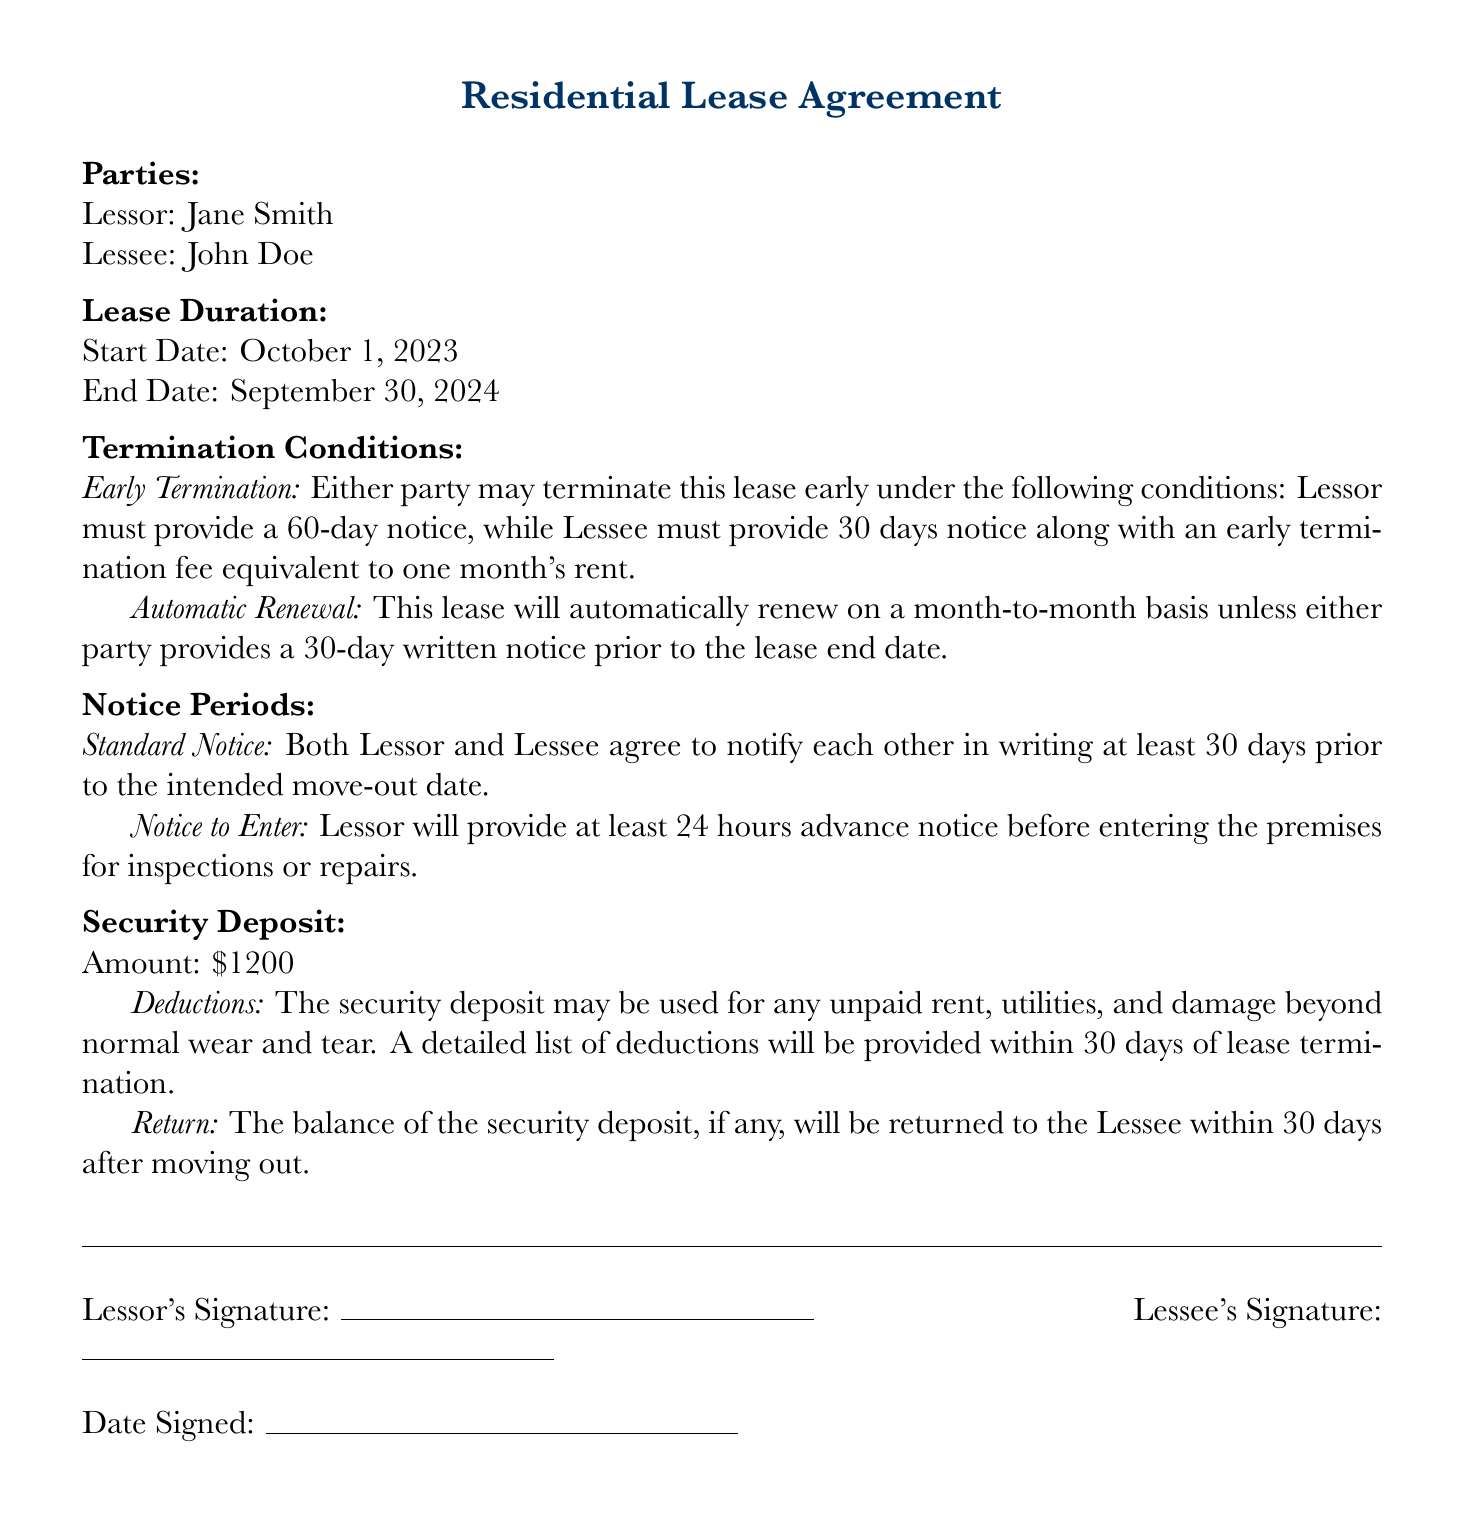What is the start date of the lease? The start date of the lease is listed under Lease Duration, which specifies October 1, 2023.
Answer: October 1, 2023 What is the end date of the lease? The end date of the lease is mentioned under Lease Duration, which states September 30, 2024.
Answer: September 30, 2024 What notice period does the Lessor need to provide for early termination? The document states that the Lessor must provide a 60-day notice for early termination.
Answer: 60 days What is the early termination fee for the Lessee? The document specifies that the Lessee must pay an early termination fee equivalent to one month's rent.
Answer: one month's rent How long after lease termination will the security deposit be returned? The document mentions that the balance of the security deposit will be returned within 30 days after moving out.
Answer: 30 days What amount is specified for the security deposit? The document states the security deposit amount is $1200.
Answer: $1200 What happens if the Lessee does not give proper notice before moving out? The security deposit may be used for unpaid rent, utilities, and damage beyond normal wear and tear if proper notice is not given.
Answer: Security deposit deductions What triggers automatic renewal of the lease? The lease will automatically renew on a month-to-month basis unless either party provides a 30-day written notice prior to the lease end date.
Answer: 30-day written notice What type of document is this? The document is identified as a Residential Lease Agreement.
Answer: Residential Lease Agreement 